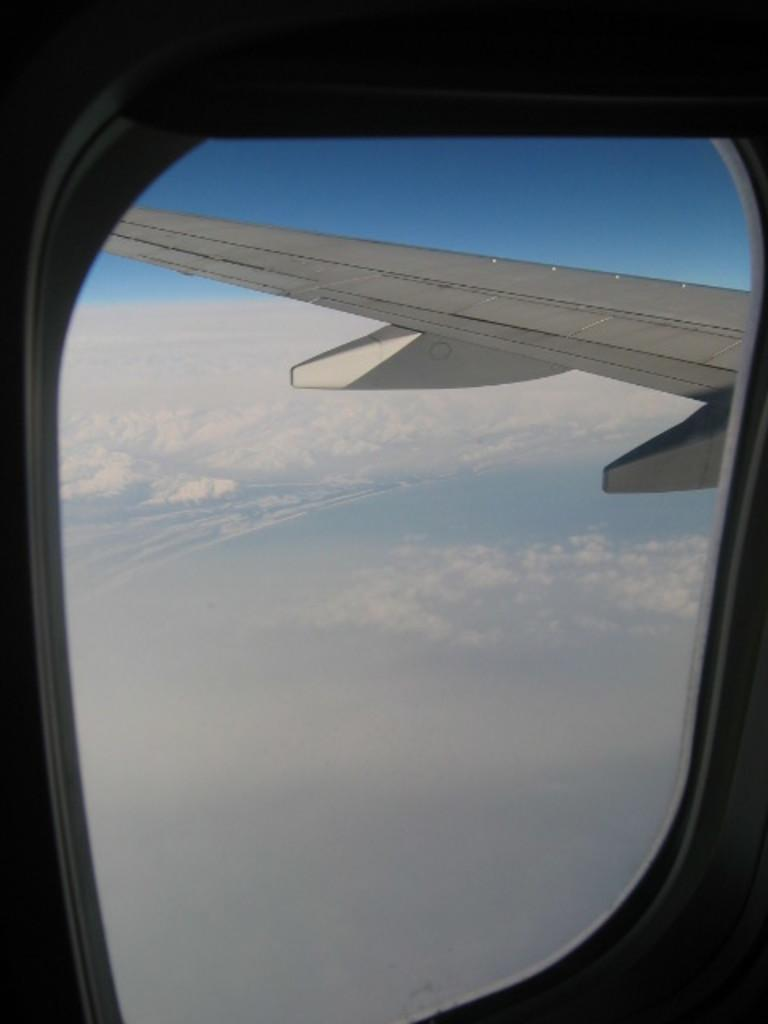What can be seen through the window in the image? A plane wing and the sky with clouds are visible through the window in the image. Can you describe the plane wing that is visible through the window? The plane wing is a part of an airplane and is visible through the window. What is the condition of the sky visible through the window? The sky visible through the window has clouds, indicating a partly cloudy day. What type of wilderness can be seen through the window in the image? There is no wilderness visible through the window in the image; it shows a plane wing and the sky with clouds. 